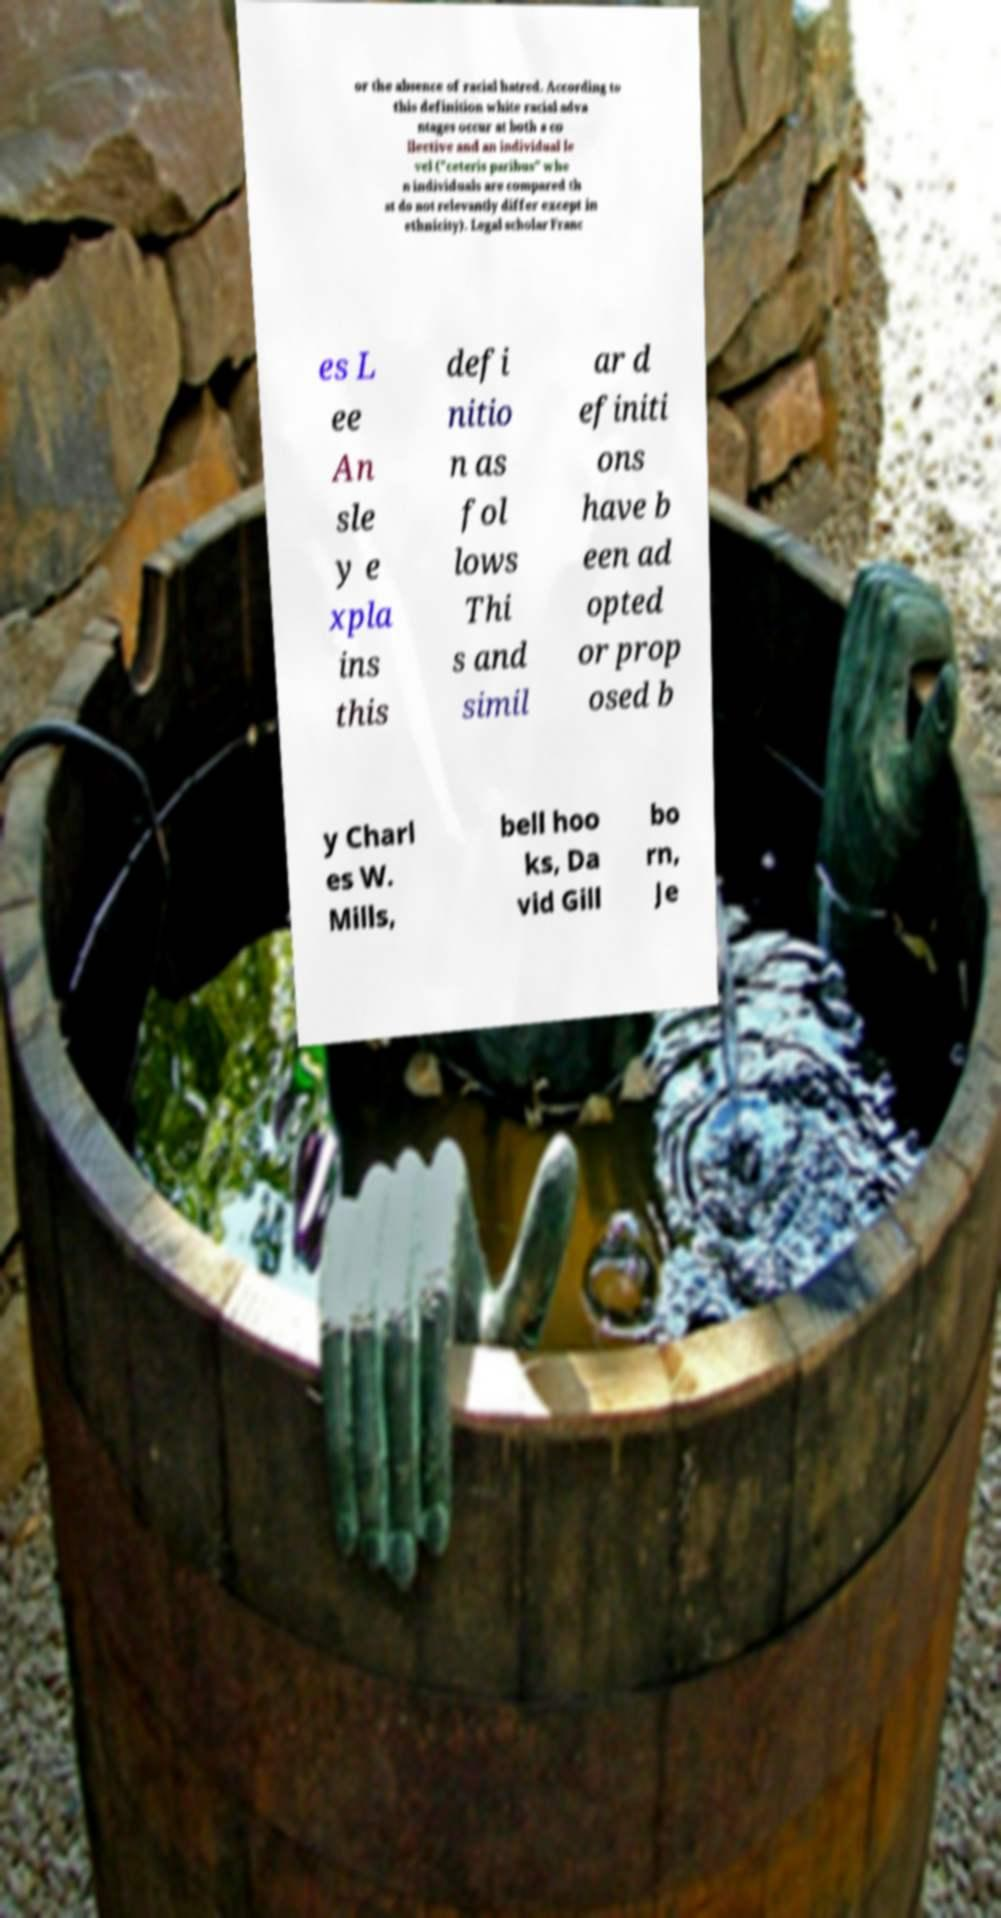Could you assist in decoding the text presented in this image and type it out clearly? or the absence of racial hatred. According to this definition white racial adva ntages occur at both a co llective and an individual le vel ("ceteris paribus" whe n individuals are compared th at do not relevantly differ except in ethnicity). Legal scholar Franc es L ee An sle y e xpla ins this defi nitio n as fol lows Thi s and simil ar d efiniti ons have b een ad opted or prop osed b y Charl es W. Mills, bell hoo ks, Da vid Gill bo rn, Je 